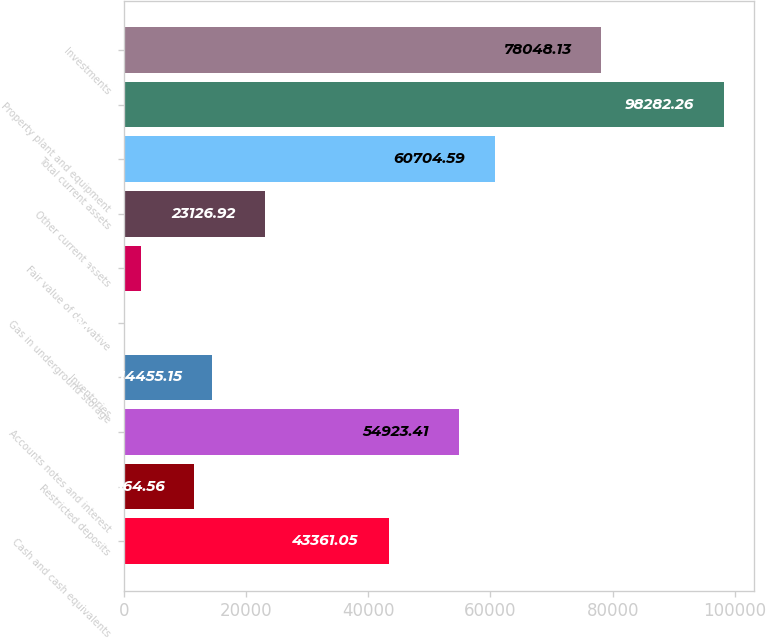Convert chart to OTSL. <chart><loc_0><loc_0><loc_500><loc_500><bar_chart><fcel>Cash and cash equivalents<fcel>Restricted deposits<fcel>Accounts notes and interest<fcel>Inventories<fcel>Gas in underground storage<fcel>Fair value of derivative<fcel>Other current assets<fcel>Total current assets<fcel>Property plant and equipment<fcel>Investments<nl><fcel>43361.1<fcel>11564.6<fcel>54923.4<fcel>14455.1<fcel>2.2<fcel>2892.79<fcel>23126.9<fcel>60704.6<fcel>98282.3<fcel>78048.1<nl></chart> 